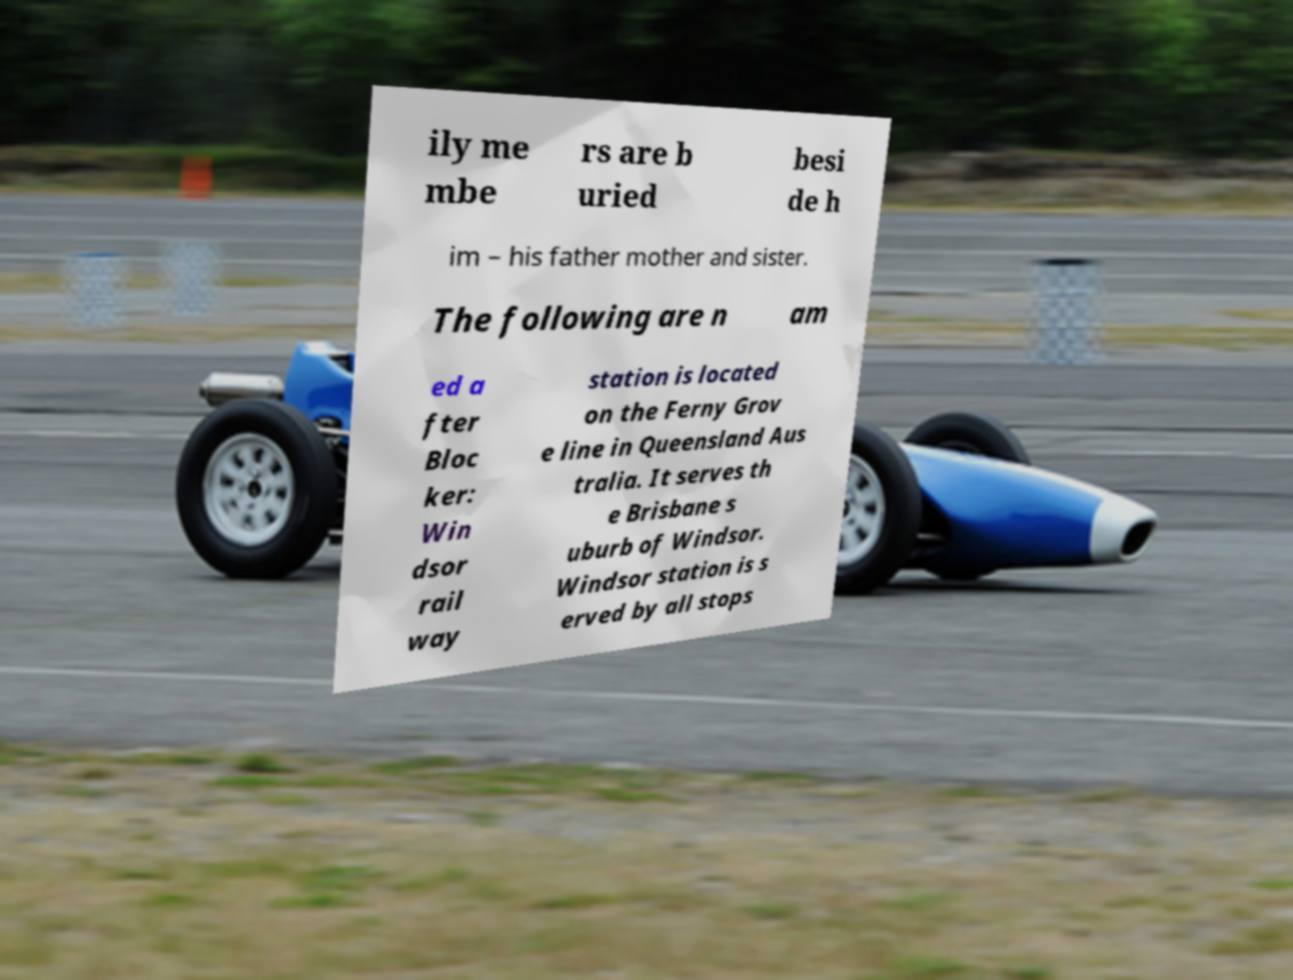Could you extract and type out the text from this image? ily me mbe rs are b uried besi de h im – his father mother and sister. The following are n am ed a fter Bloc ker: Win dsor rail way station is located on the Ferny Grov e line in Queensland Aus tralia. It serves th e Brisbane s uburb of Windsor. Windsor station is s erved by all stops 